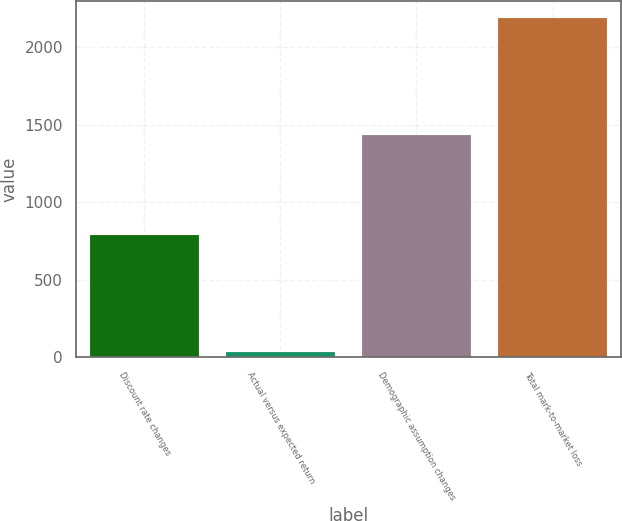Convert chart. <chart><loc_0><loc_0><loc_500><loc_500><bar_chart><fcel>Discount rate changes<fcel>Actual versus expected return<fcel>Demographic assumption changes<fcel>Total mark-to-market loss<nl><fcel>791<fcel>35<fcel>1434<fcel>2190<nl></chart> 